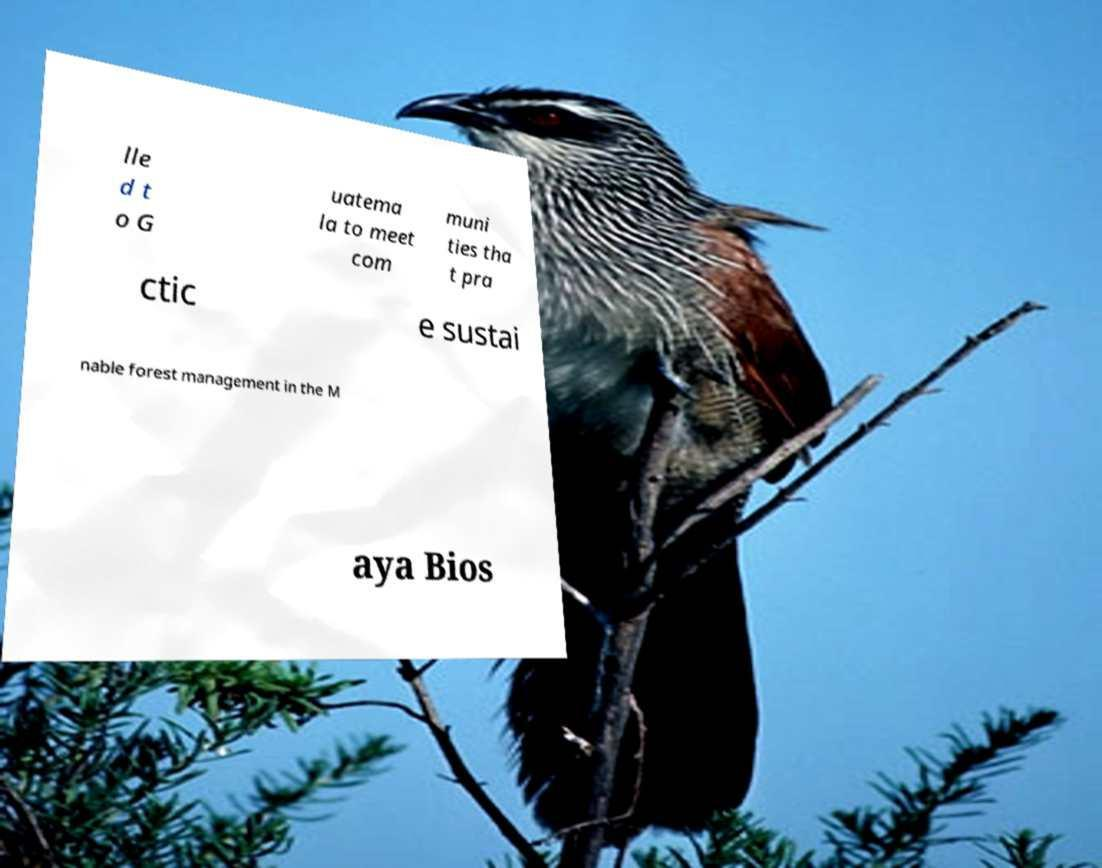Could you assist in decoding the text presented in this image and type it out clearly? lle d t o G uatema la to meet com muni ties tha t pra ctic e sustai nable forest management in the M aya Bios 